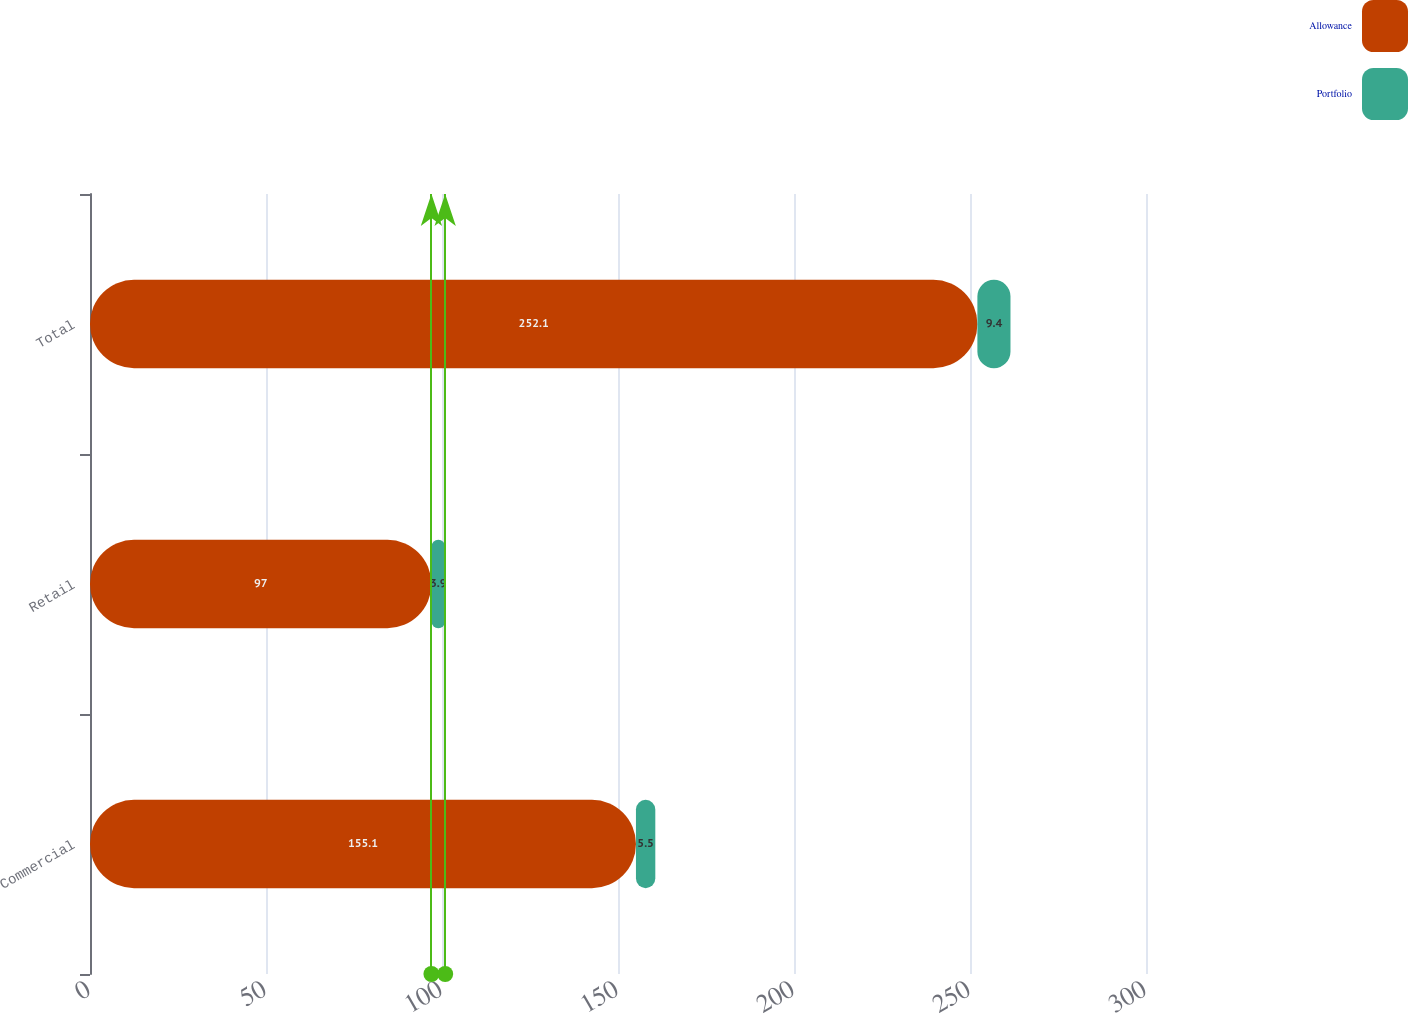Convert chart to OTSL. <chart><loc_0><loc_0><loc_500><loc_500><stacked_bar_chart><ecel><fcel>Commercial<fcel>Retail<fcel>Total<nl><fcel>Allowance<fcel>155.1<fcel>97<fcel>252.1<nl><fcel>Portfolio<fcel>5.5<fcel>3.9<fcel>9.4<nl></chart> 